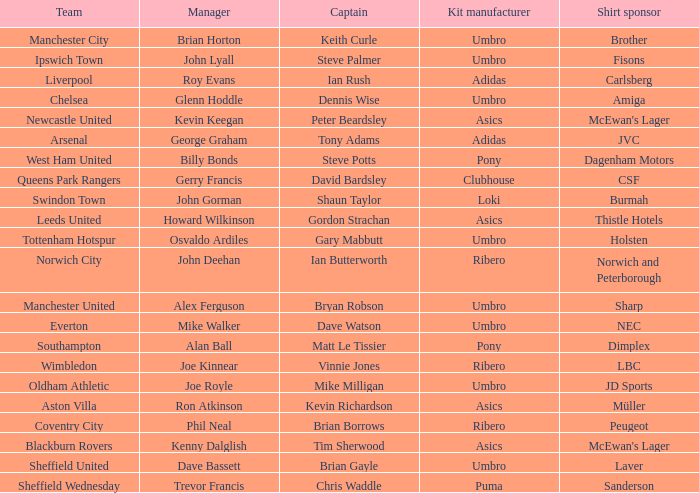Which captain has howard wilkinson as the manager? Gordon Strachan. 